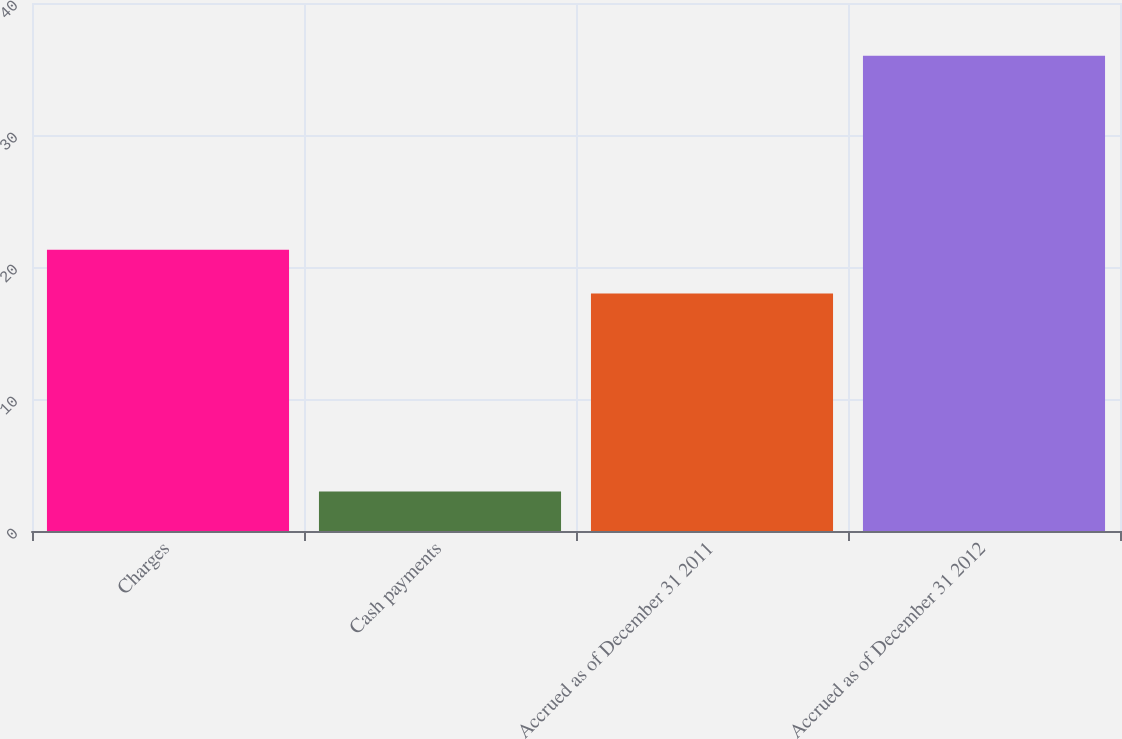Convert chart to OTSL. <chart><loc_0><loc_0><loc_500><loc_500><bar_chart><fcel>Charges<fcel>Cash payments<fcel>Accrued as of December 31 2011<fcel>Accrued as of December 31 2012<nl><fcel>21.3<fcel>3<fcel>18<fcel>36<nl></chart> 